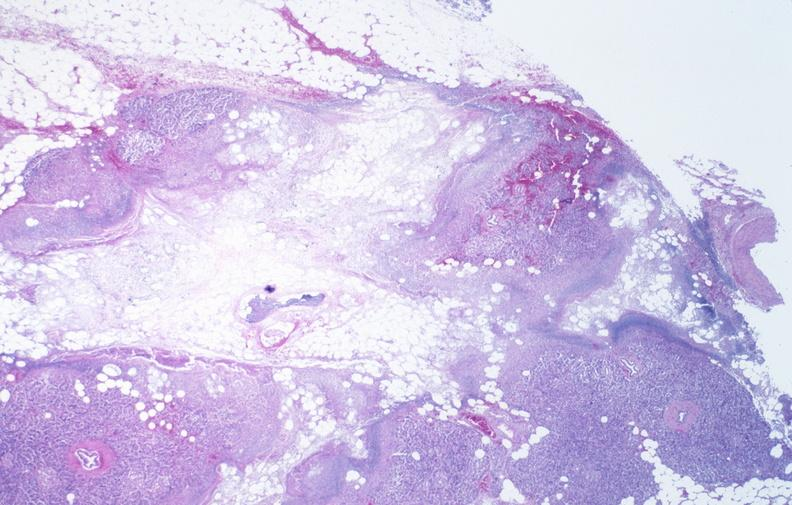does small intestine show pancreatic fat necrosis?
Answer the question using a single word or phrase. No 